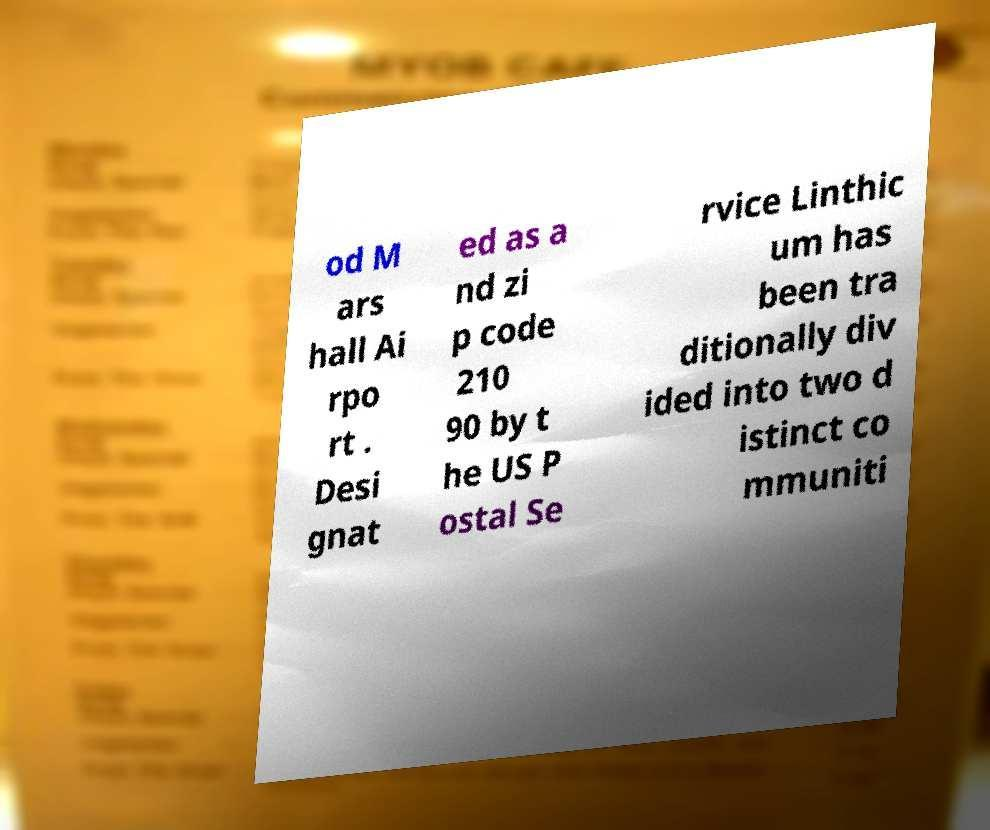Could you extract and type out the text from this image? od M ars hall Ai rpo rt . Desi gnat ed as a nd zi p code 210 90 by t he US P ostal Se rvice Linthic um has been tra ditionally div ided into two d istinct co mmuniti 